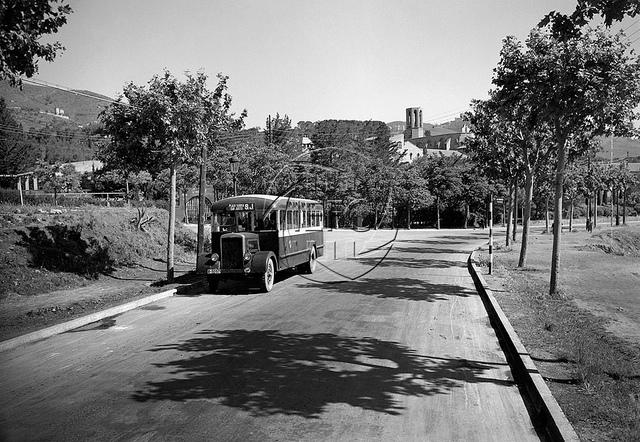Is the road paved?
Short answer required. Yes. How old is this bus?
Keep it brief. 20. Do trees line both sides of the street, or only one side?
Write a very short answer. Both. 